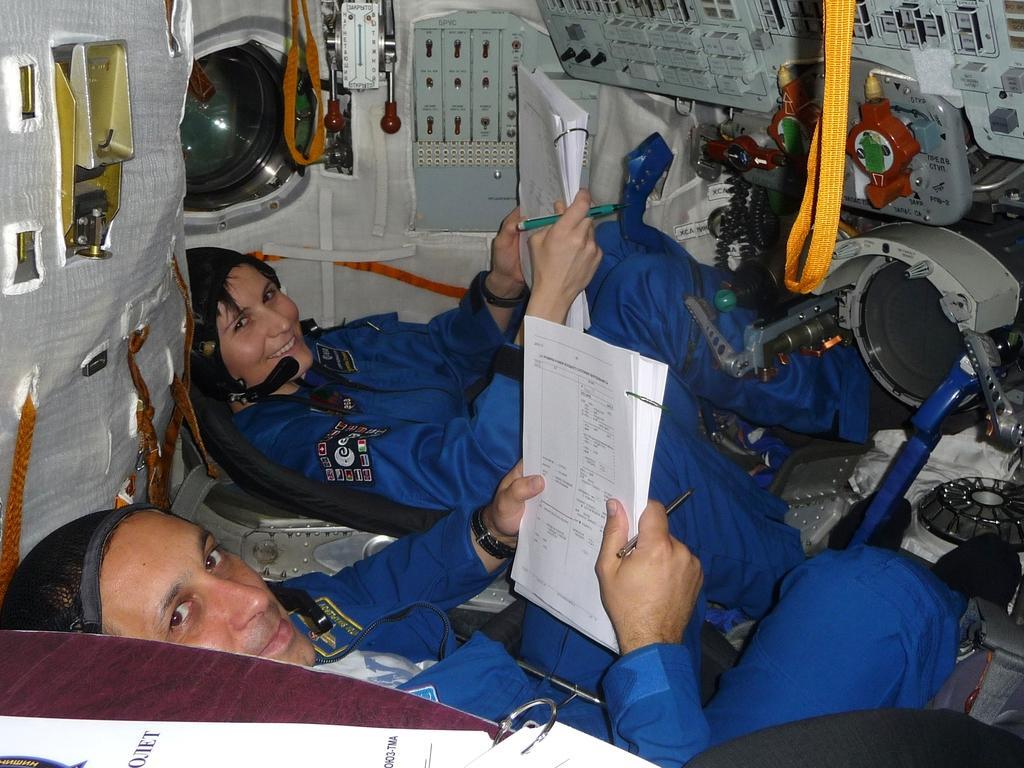In one or two sentences, can you explain what this image depicts? In this image we can see two persons sitting and holding some things in their hands and it looks like a inner view of a spacecraft. We can see some machines and some other objects. 